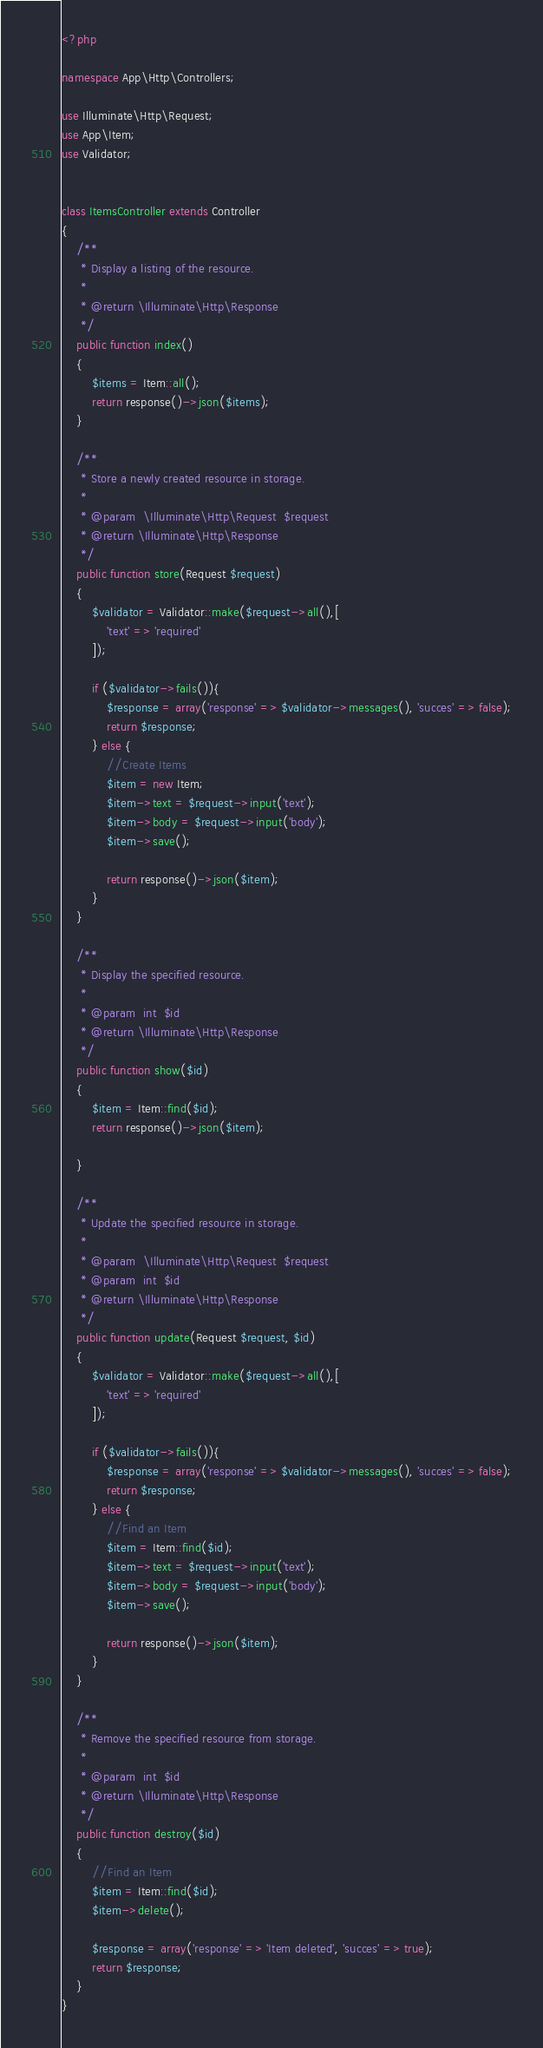Convert code to text. <code><loc_0><loc_0><loc_500><loc_500><_PHP_><?php

namespace App\Http\Controllers;

use Illuminate\Http\Request;
use App\Item;
use Validator;


class ItemsController extends Controller
{
    /**
     * Display a listing of the resource.
     *
     * @return \Illuminate\Http\Response
     */
    public function index()
    {
        $items = Item::all();
        return response()->json($items);
    }

    /**
     * Store a newly created resource in storage.
     *
     * @param  \Illuminate\Http\Request  $request
     * @return \Illuminate\Http\Response
     */
    public function store(Request $request)
    {
        $validator = Validator::make($request->all(),[
            'text' => 'required'
        ]);

        if ($validator->fails()){
            $response = array('response' => $validator->messages(), 'succes' => false);
            return $response;
        } else {
            //Create Items
            $item = new Item;
            $item->text = $request->input('text');
            $item->body = $request->input('body');
            $item->save();

            return response()->json($item);
        }
    }

    /**
     * Display the specified resource.
     *
     * @param  int  $id
     * @return \Illuminate\Http\Response
     */
    public function show($id)
    {
        $item = Item::find($id);
        return response()->json($item);

    }

    /**
     * Update the specified resource in storage.
     *
     * @param  \Illuminate\Http\Request  $request
     * @param  int  $id
     * @return \Illuminate\Http\Response
     */
    public function update(Request $request, $id)
    {
        $validator = Validator::make($request->all(),[
            'text' => 'required'
        ]);

        if ($validator->fails()){
            $response = array('response' => $validator->messages(), 'succes' => false);
            return $response;
        } else {
            //Find an Item
            $item = Item::find($id);
            $item->text = $request->input('text');
            $item->body = $request->input('body');
            $item->save();

            return response()->json($item);
        }
    }

    /**
     * Remove the specified resource from storage.
     *
     * @param  int  $id
     * @return \Illuminate\Http\Response
     */
    public function destroy($id)
    {
        //Find an Item
        $item = Item::find($id);
        $item->delete();

        $response = array('response' => 'Item deleted', 'succes' => true);
        return $response;
    }
}
</code> 